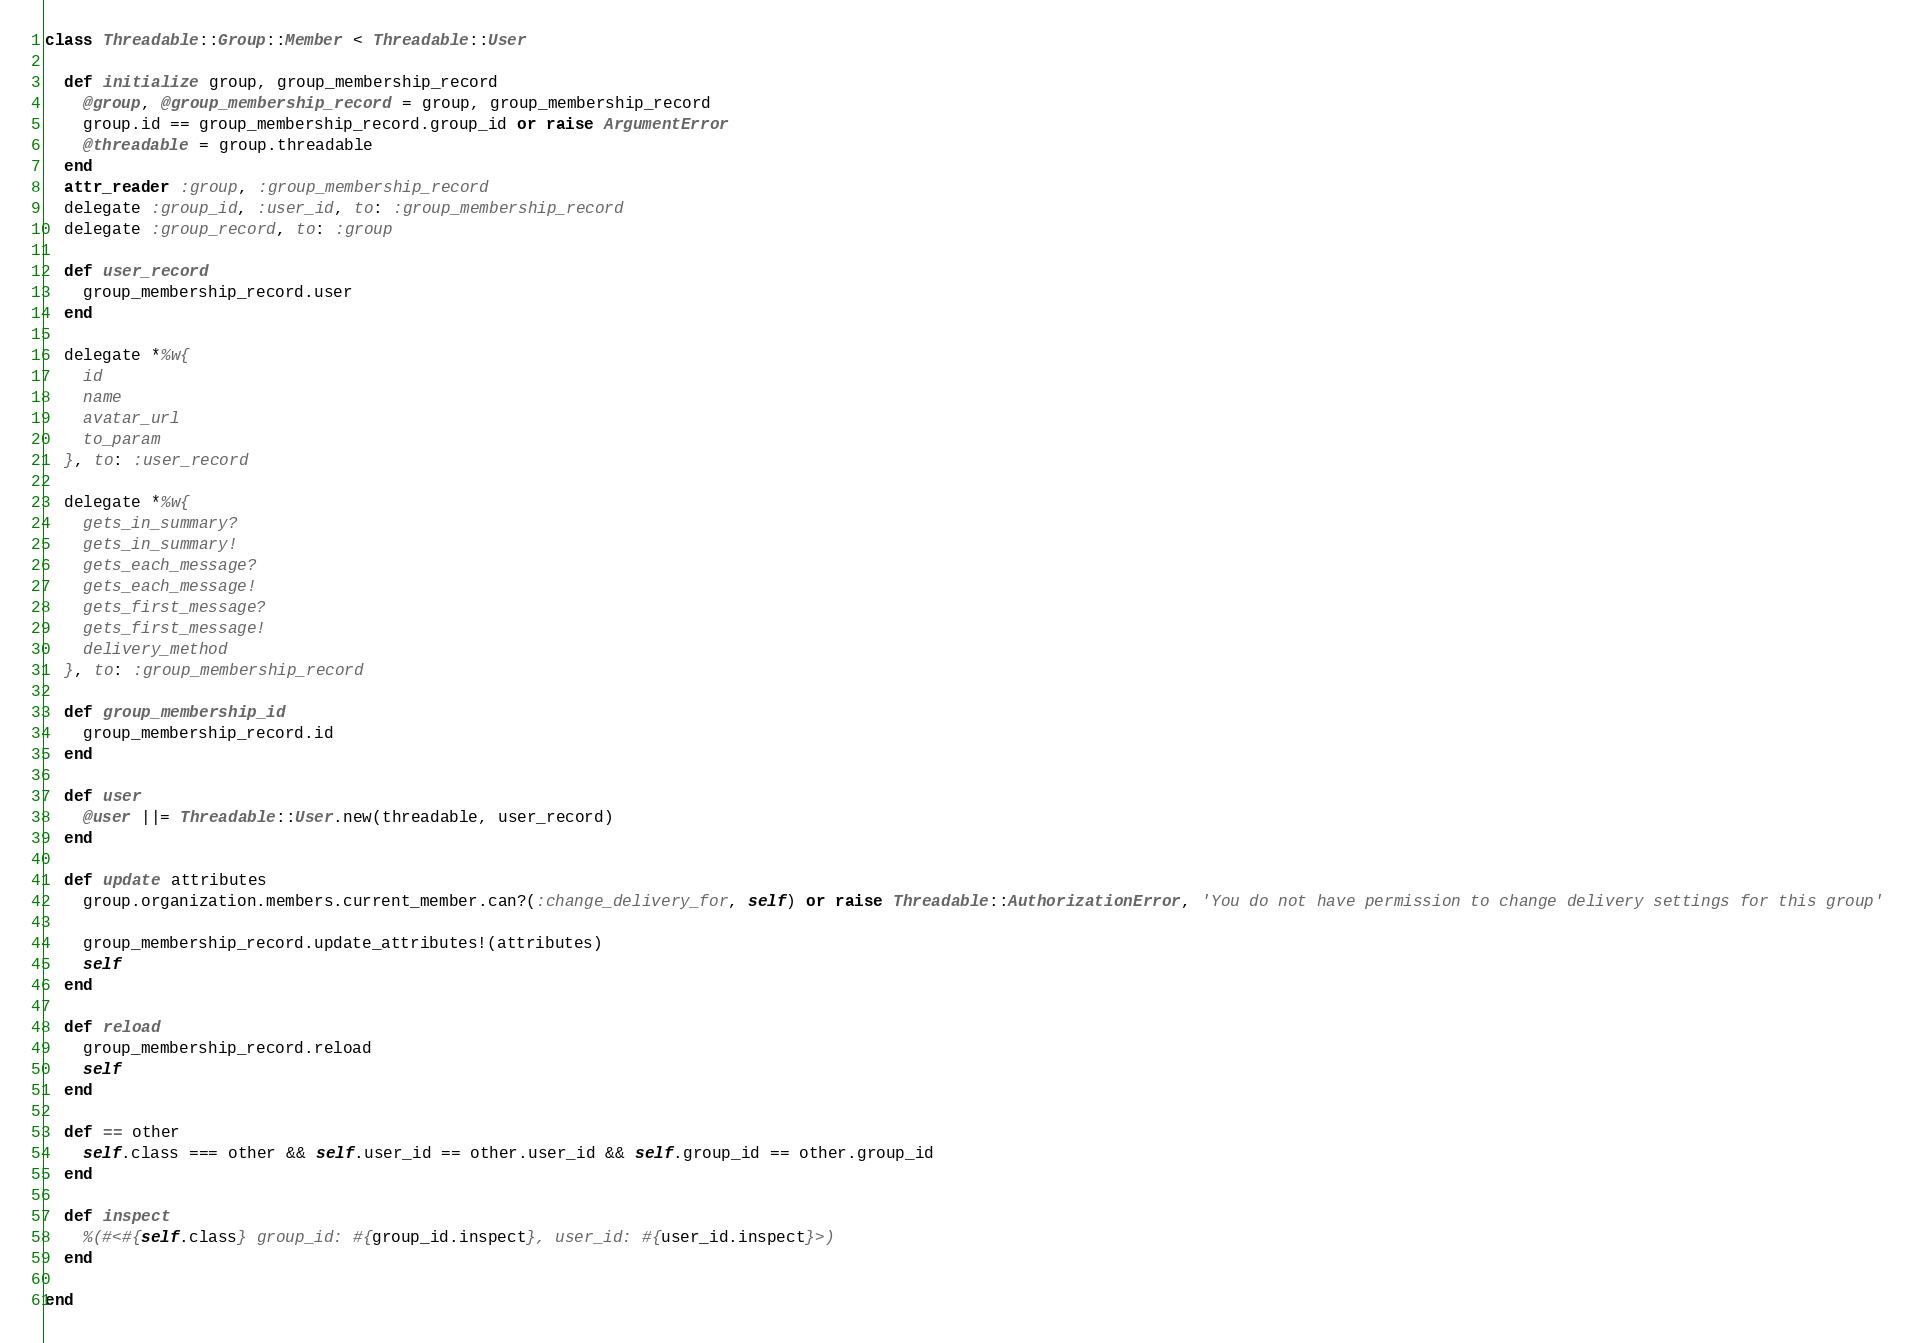<code> <loc_0><loc_0><loc_500><loc_500><_Ruby_>class Threadable::Group::Member < Threadable::User

  def initialize group, group_membership_record
    @group, @group_membership_record = group, group_membership_record
    group.id == group_membership_record.group_id or raise ArgumentError
    @threadable = group.threadable
  end
  attr_reader :group, :group_membership_record
  delegate :group_id, :user_id, to: :group_membership_record
  delegate :group_record, to: :group

  def user_record
    group_membership_record.user
  end

  delegate *%w{
    id
    name
    avatar_url
    to_param
  }, to: :user_record

  delegate *%w{
    gets_in_summary?
    gets_in_summary!
    gets_each_message?
    gets_each_message!
    gets_first_message?
    gets_first_message!
    delivery_method
  }, to: :group_membership_record

  def group_membership_id
    group_membership_record.id
  end

  def user
    @user ||= Threadable::User.new(threadable, user_record)
  end

  def update attributes
    group.organization.members.current_member.can?(:change_delivery_for, self) or raise Threadable::AuthorizationError, 'You do not have permission to change delivery settings for this group'

    group_membership_record.update_attributes!(attributes)
    self
  end

  def reload
    group_membership_record.reload
    self
  end

  def == other
    self.class === other && self.user_id == other.user_id && self.group_id == other.group_id
  end

  def inspect
    %(#<#{self.class} group_id: #{group_id.inspect}, user_id: #{user_id.inspect}>)
  end

end
</code> 